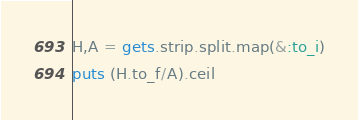<code> <loc_0><loc_0><loc_500><loc_500><_Ruby_>H,A = gets.strip.split.map(&:to_i)
puts (H.to_f/A).ceil</code> 